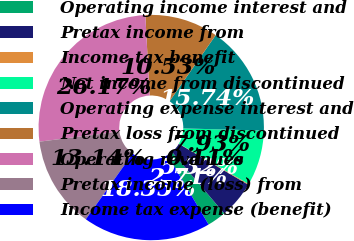Convert chart to OTSL. <chart><loc_0><loc_0><loc_500><loc_500><pie_chart><fcel>Operating income interest and<fcel>Pretax income from<fcel>Income tax benefit<fcel>Net income from discontinued<fcel>Operating expense interest and<fcel>Pretax loss from discontinued<fcel>Operating revenues<fcel>Pretax income (loss) from<fcel>Income tax expense (benefit)<nl><fcel>2.71%<fcel>5.32%<fcel>0.11%<fcel>7.93%<fcel>15.74%<fcel>10.53%<fcel>26.17%<fcel>13.14%<fcel>18.35%<nl></chart> 